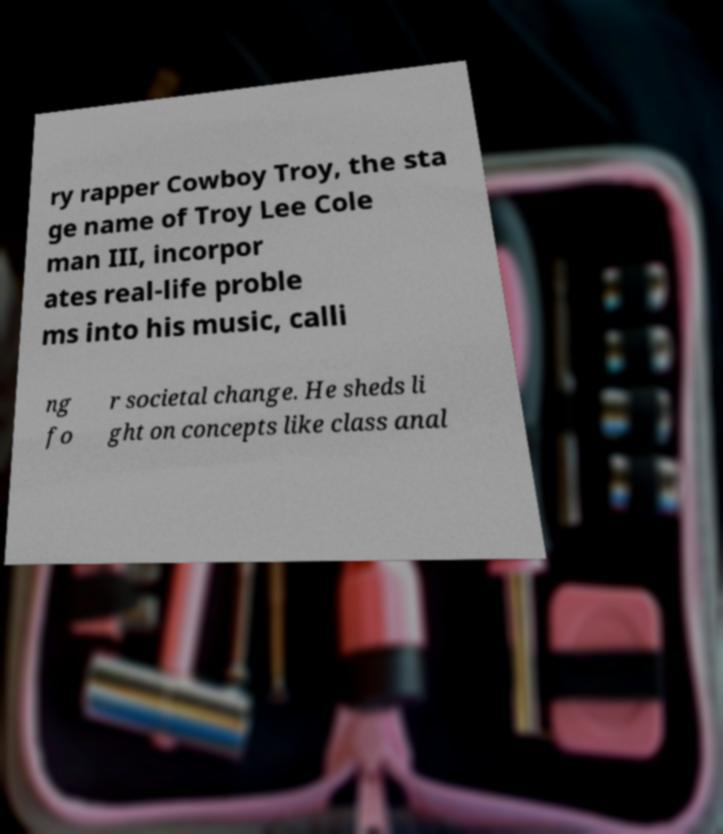There's text embedded in this image that I need extracted. Can you transcribe it verbatim? ry rapper Cowboy Troy, the sta ge name of Troy Lee Cole man III, incorpor ates real-life proble ms into his music, calli ng fo r societal change. He sheds li ght on concepts like class anal 